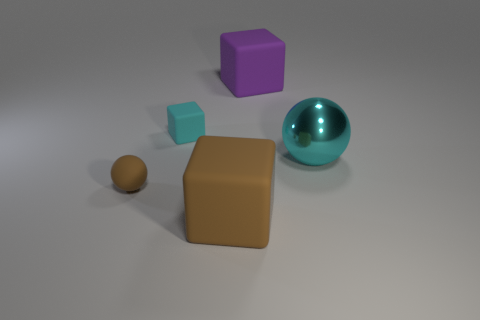Is there any other thing that has the same material as the cyan sphere?
Provide a succinct answer. No. There is a large ball that is the same color as the tiny matte block; what material is it?
Give a very brief answer. Metal. The cyan shiny thing that is the same shape as the small brown matte thing is what size?
Your answer should be very brief. Large. What number of other things are there of the same color as the small ball?
Keep it short and to the point. 1. How many tiny rubber objects are behind the cyan metallic thing and left of the tiny cyan block?
Your response must be concise. 0. What number of purple matte objects have the same shape as the big brown matte thing?
Ensure brevity in your answer.  1. Is the material of the big purple cube the same as the tiny brown ball?
Provide a short and direct response. Yes. The cyan thing that is to the left of the brown thing in front of the tiny matte ball is what shape?
Your response must be concise. Cube. What number of big matte objects are in front of the small matte thing that is behind the shiny thing?
Offer a terse response. 1. What is the material of the object that is left of the large brown cube and in front of the big cyan shiny thing?
Your answer should be very brief. Rubber. 